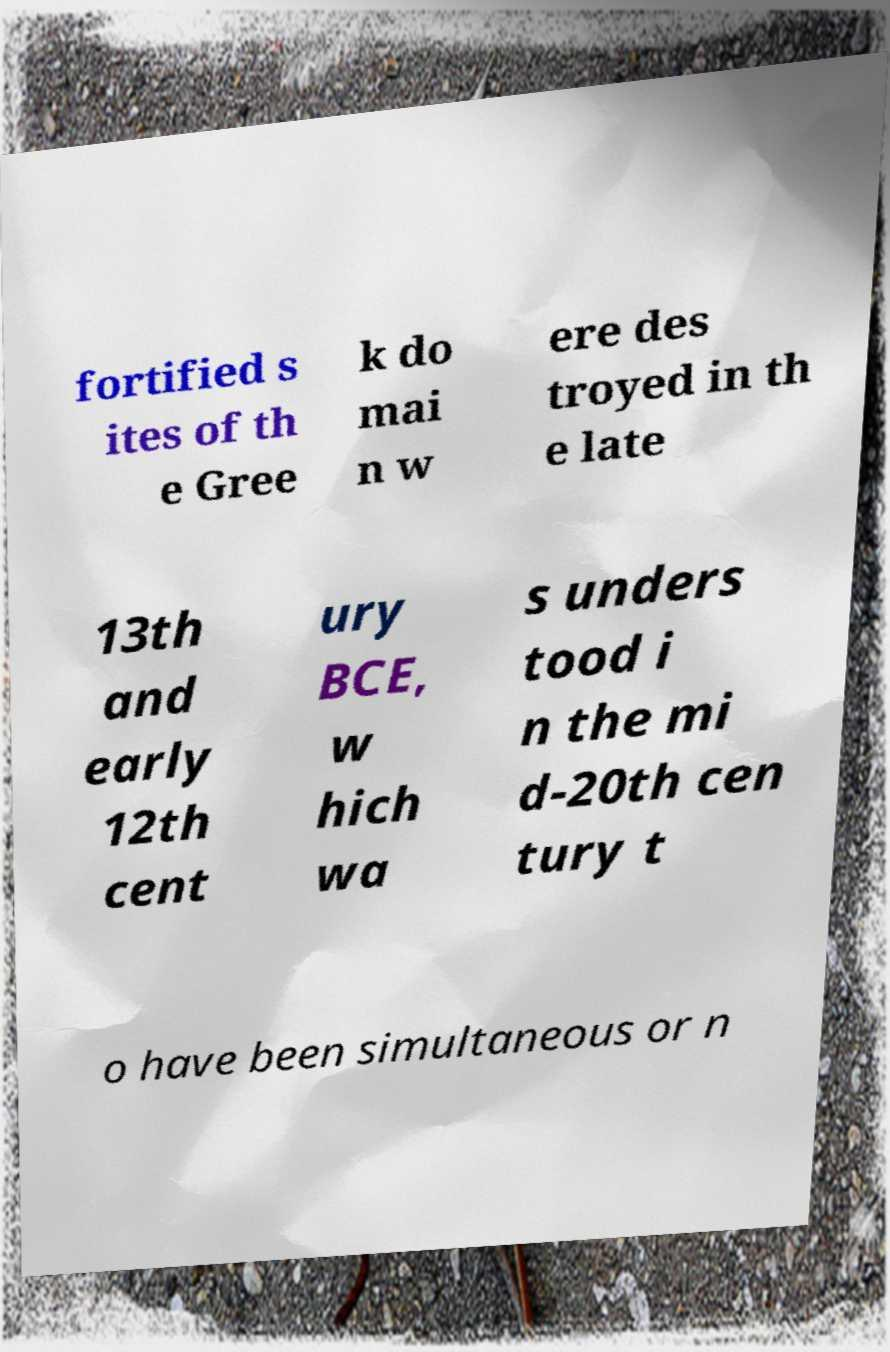What messages or text are displayed in this image? I need them in a readable, typed format. fortified s ites of th e Gree k do mai n w ere des troyed in th e late 13th and early 12th cent ury BCE, w hich wa s unders tood i n the mi d-20th cen tury t o have been simultaneous or n 